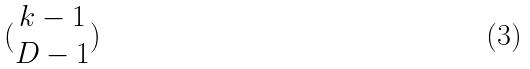<formula> <loc_0><loc_0><loc_500><loc_500>( \begin{matrix} k - 1 \\ D - 1 \end{matrix} )</formula> 